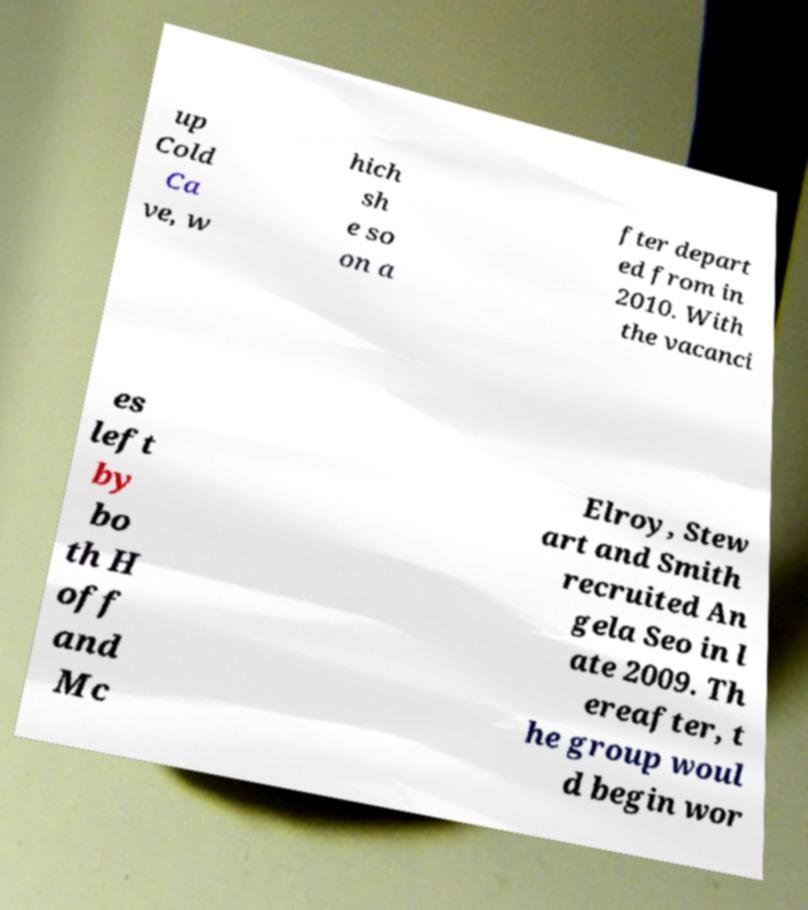Could you assist in decoding the text presented in this image and type it out clearly? up Cold Ca ve, w hich sh e so on a fter depart ed from in 2010. With the vacanci es left by bo th H off and Mc Elroy, Stew art and Smith recruited An gela Seo in l ate 2009. Th ereafter, t he group woul d begin wor 